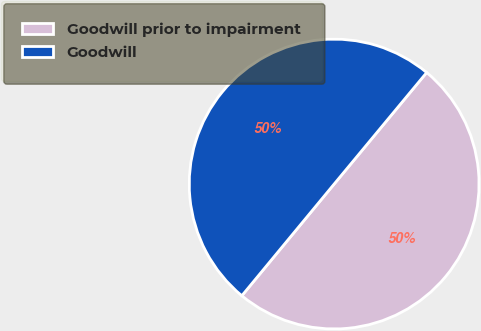Convert chart to OTSL. <chart><loc_0><loc_0><loc_500><loc_500><pie_chart><fcel>Goodwill prior to impairment<fcel>Goodwill<nl><fcel>49.97%<fcel>50.03%<nl></chart> 